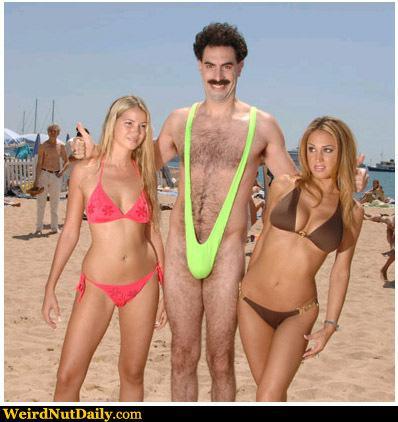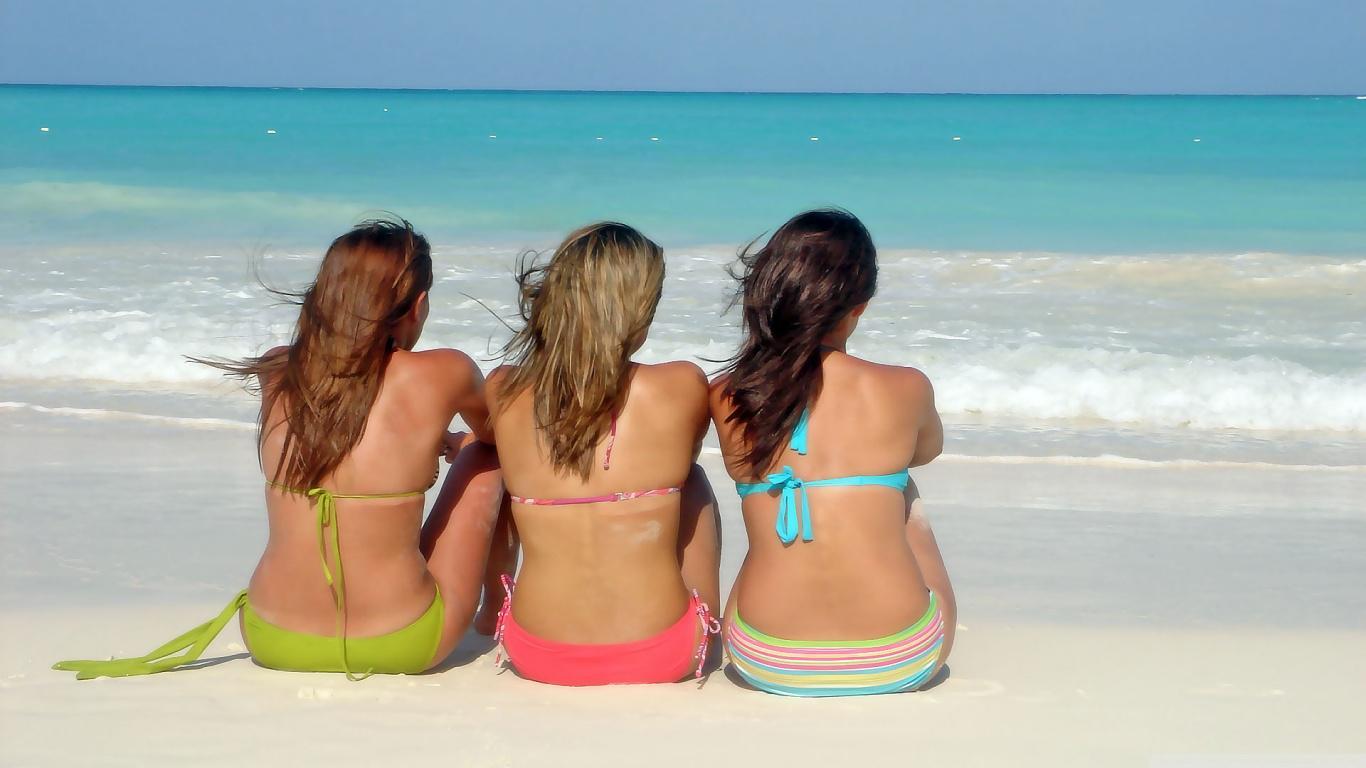The first image is the image on the left, the second image is the image on the right. Evaluate the accuracy of this statement regarding the images: "In 1 of the images, 1 girl with a pink bikini and 1 girl with a green bikini is sitting.". Is it true? Answer yes or no. Yes. 